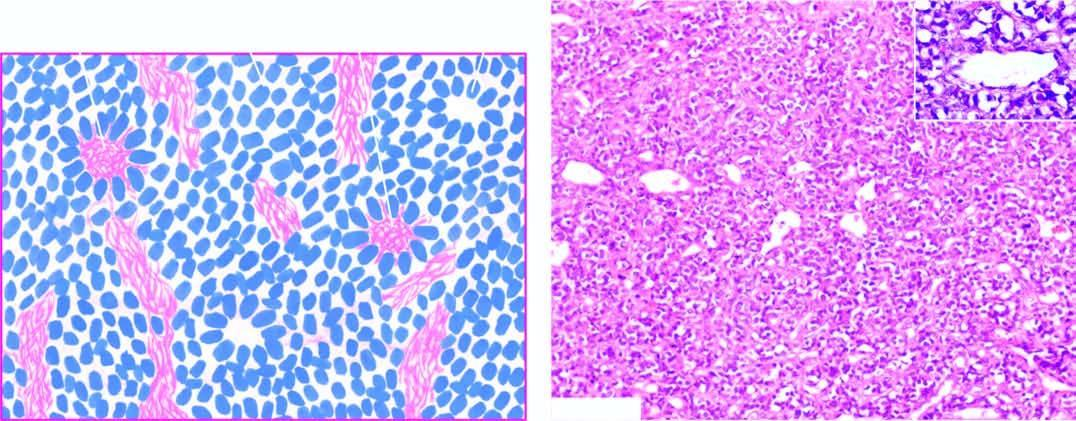what are also present?
Answer the question using a single word or phrase. A few homerwright 's pseudorosettes 